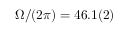Convert formula to latex. <formula><loc_0><loc_0><loc_500><loc_500>\Omega / ( 2 \pi ) = 4 6 . 1 ( 2 )</formula> 